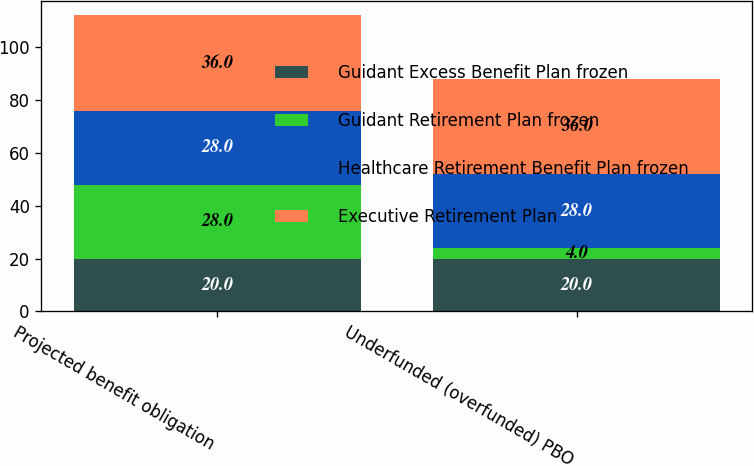Convert chart. <chart><loc_0><loc_0><loc_500><loc_500><stacked_bar_chart><ecel><fcel>Projected benefit obligation<fcel>Underfunded (overfunded) PBO<nl><fcel>Guidant Excess Benefit Plan frozen<fcel>20<fcel>20<nl><fcel>Guidant Retirement Plan frozen<fcel>28<fcel>4<nl><fcel>Healthcare Retirement Benefit Plan frozen<fcel>28<fcel>28<nl><fcel>Executive Retirement Plan<fcel>36<fcel>36<nl></chart> 